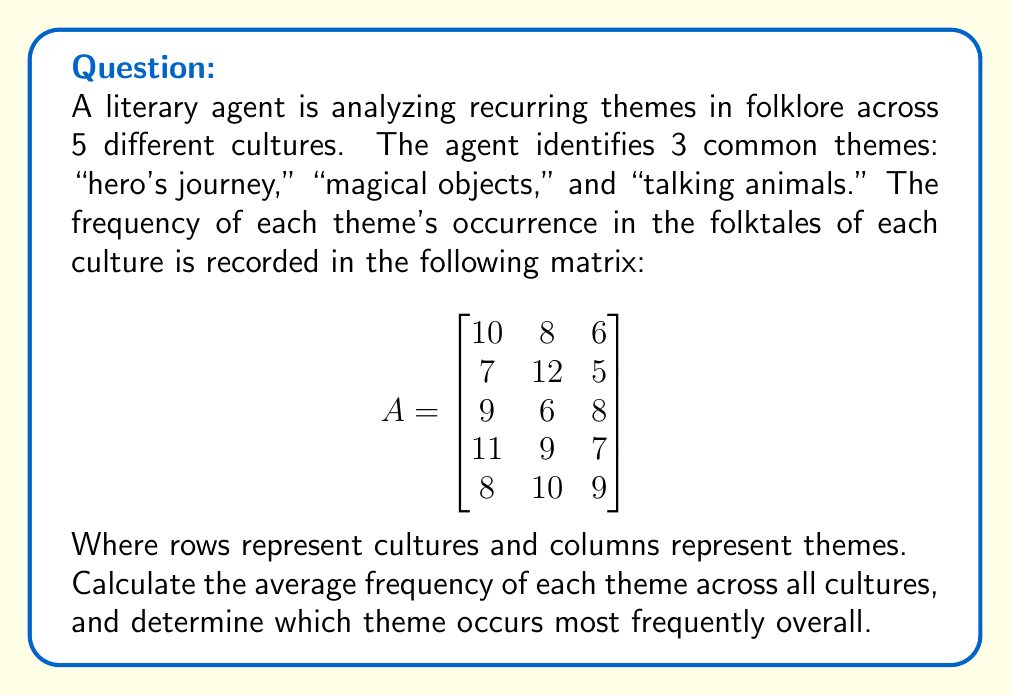Help me with this question. To solve this problem, we'll follow these steps:

1. Calculate the sum of each column in the matrix.
2. Divide each sum by the number of cultures (5) to get the average frequency for each theme.
3. Compare the averages to determine the most frequent theme.

Step 1: Sum of each column

For "hero's journey" (column 1): $10 + 7 + 9 + 11 + 8 = 45$
For "magical objects" (column 2): $8 + 12 + 6 + 9 + 10 = 45$
For "talking animals" (column 3): $6 + 5 + 8 + 7 + 9 = 35$

Step 2: Calculate averages

Average for "hero's journey": $\frac{45}{5} = 9$
Average for "magical objects": $\frac{45}{5} = 9$
Average for "talking animals": $\frac{35}{5} = 7$

Step 3: Compare averages

The highest average is 9, shared by both "hero's journey" and "magical objects."

Therefore, "hero's journey" and "magical objects" occur most frequently overall, with an average of 9 occurrences per culture.
Answer: Average frequencies: "hero's journey" = 9, "magical objects" = 9, "talking animals" = 7.
Most frequent themes: "hero's journey" and "magical objects" (tie), with an average of 9 occurrences per culture. 